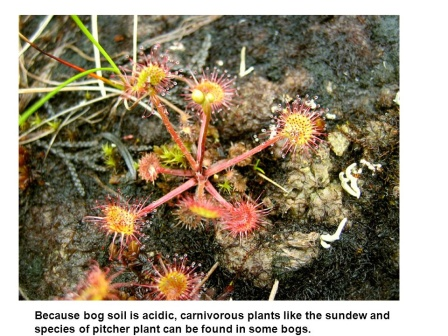Can you describe the main features of this image for me? The image vividly captures the unique ecosystem of a bog, showcasing a variety of carnivorous plants thriving in this acidic environment. Dominating the scene are the sundews, with their long, slender leaves adorned with sparkling, sticky droplets. These droplets trap insects that come too close, providing the plants with essential nutrients. The sundews' reddish hues contrast beautifully with the surrounding greenery. Nearby, pitcher plants, with their distinctive tube-like leaves, can be seen. These leaves form natural traps for insects, luring them in with their bright red and green colors before capturing them inside. The ground is covered in a lush carpet of green moss, providing a soft and vibrant background that highlights the harsh survival strategies of these fascinating plants. The text overlay explains that the acidic conditions of the bog make it a suitable habitat for these specialized carnivorous plants, emphasizing their adaptability and resilience. 